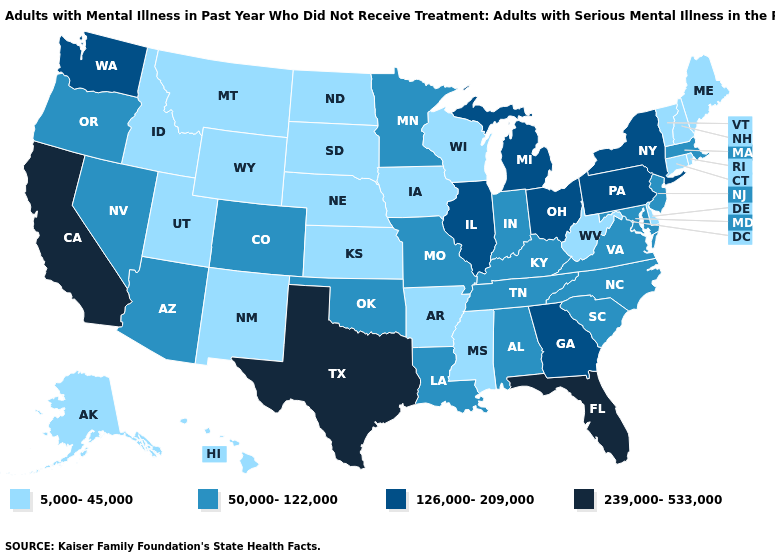Name the states that have a value in the range 239,000-533,000?
Concise answer only. California, Florida, Texas. Which states have the lowest value in the West?
Concise answer only. Alaska, Hawaii, Idaho, Montana, New Mexico, Utah, Wyoming. Which states hav the highest value in the West?
Short answer required. California. Name the states that have a value in the range 50,000-122,000?
Give a very brief answer. Alabama, Arizona, Colorado, Indiana, Kentucky, Louisiana, Maryland, Massachusetts, Minnesota, Missouri, Nevada, New Jersey, North Carolina, Oklahoma, Oregon, South Carolina, Tennessee, Virginia. Which states have the lowest value in the South?
Quick response, please. Arkansas, Delaware, Mississippi, West Virginia. Does Alabama have a lower value than Tennessee?
Short answer required. No. Which states have the highest value in the USA?
Short answer required. California, Florida, Texas. Name the states that have a value in the range 239,000-533,000?
Quick response, please. California, Florida, Texas. What is the value of Colorado?
Write a very short answer. 50,000-122,000. Name the states that have a value in the range 50,000-122,000?
Answer briefly. Alabama, Arizona, Colorado, Indiana, Kentucky, Louisiana, Maryland, Massachusetts, Minnesota, Missouri, Nevada, New Jersey, North Carolina, Oklahoma, Oregon, South Carolina, Tennessee, Virginia. Which states have the highest value in the USA?
Give a very brief answer. California, Florida, Texas. Among the states that border Indiana , does Kentucky have the lowest value?
Keep it brief. Yes. Is the legend a continuous bar?
Write a very short answer. No. What is the value of Hawaii?
Keep it brief. 5,000-45,000. What is the value of Oklahoma?
Keep it brief. 50,000-122,000. 